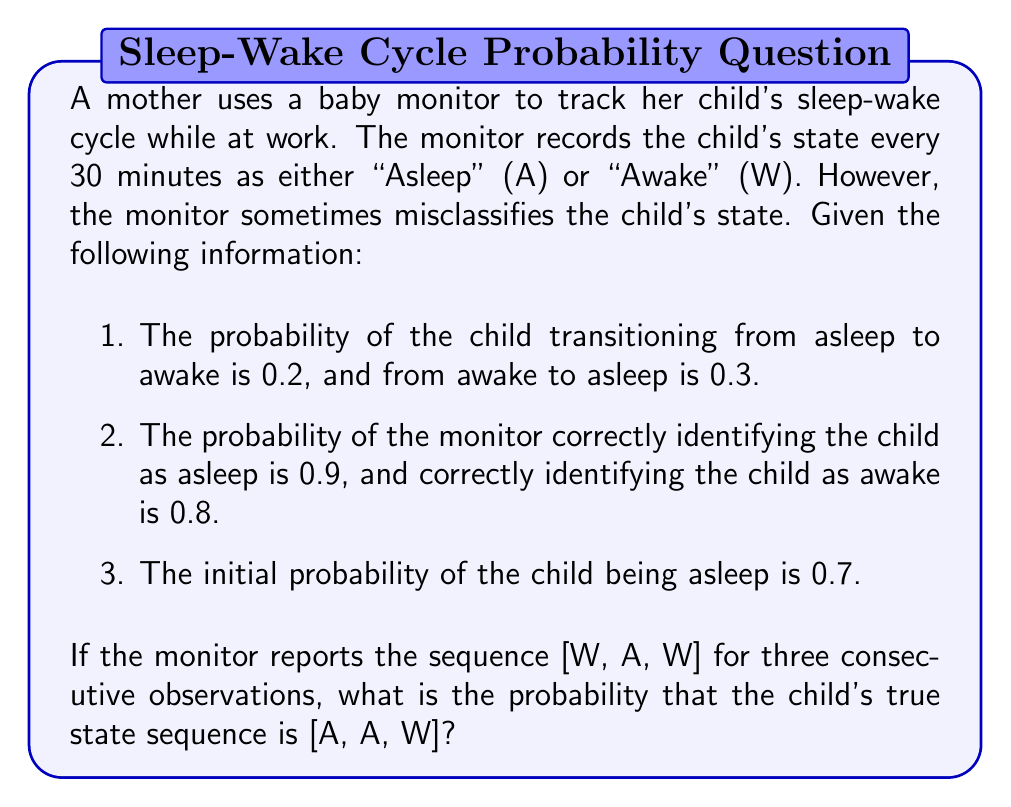Give your solution to this math problem. To solve this problem, we'll use a hidden Markov model (HMM) and apply the forward algorithm. Let's break it down step-by-step:

1. Define the HMM parameters:
   - States: S = {A, W}
   - Observations: O = {A, W}
   - Initial probabilities: π = [0.7, 0.3]
   - Transition matrix: 
     A = $$\begin{bmatrix} 0.8 & 0.2 \\ 0.3 & 0.7 \end{bmatrix}$$
   - Emission matrix: 
     B = $$\begin{bmatrix} 0.9 & 0.1 \\ 0.2 & 0.8 \end{bmatrix}$$

2. Calculate the forward probabilities:
   Let $α_t(i)$ be the probability of being in state i at time t and observing the sequence up to time t.

   For t = 1 (W observed):
   $α_1(A) = 0.7 * 0.1 = 0.07$
   $α_1(W) = 0.3 * 0.8 = 0.24$

   For t = 2 (A observed):
   $α_2(A) = (0.07 * 0.8 + 0.24 * 0.3) * 0.9 = 0.1134$
   $α_2(W) = (0.07 * 0.2 + 0.24 * 0.7) * 0.1 = 0.0028$

   For t = 3 (W observed):
   $α_3(A) = (0.1134 * 0.8 + 0.0028 * 0.3) * 0.1 = 0.00908$
   $α_3(W) = (0.1134 * 0.2 + 0.0028 * 0.7) * 0.8 = 0.01816$

3. Calculate the probability of the observed sequence:
   P(W, A, W) = $α_3(A) + α_3(W) = 0.00908 + 0.01816 = 0.02724$

4. Calculate the probability of the true state sequence [A, A, W] given the observations:
   P(A, A, W | W, A, W) = P(A, A, W, W, A, W) / P(W, A, W)

   P(A, A, W, W, A, W) = 0.7 * 0.1 * 0.8 * 0.9 * 0.2 * 0.8 = 0.008064

   P(A, A, W | W, A, W) = 0.008064 / 0.02724 ≈ 0.2960

5. Convert to a percentage: 0.2960 * 100% ≈ 29.60%
Answer: 29.60% 